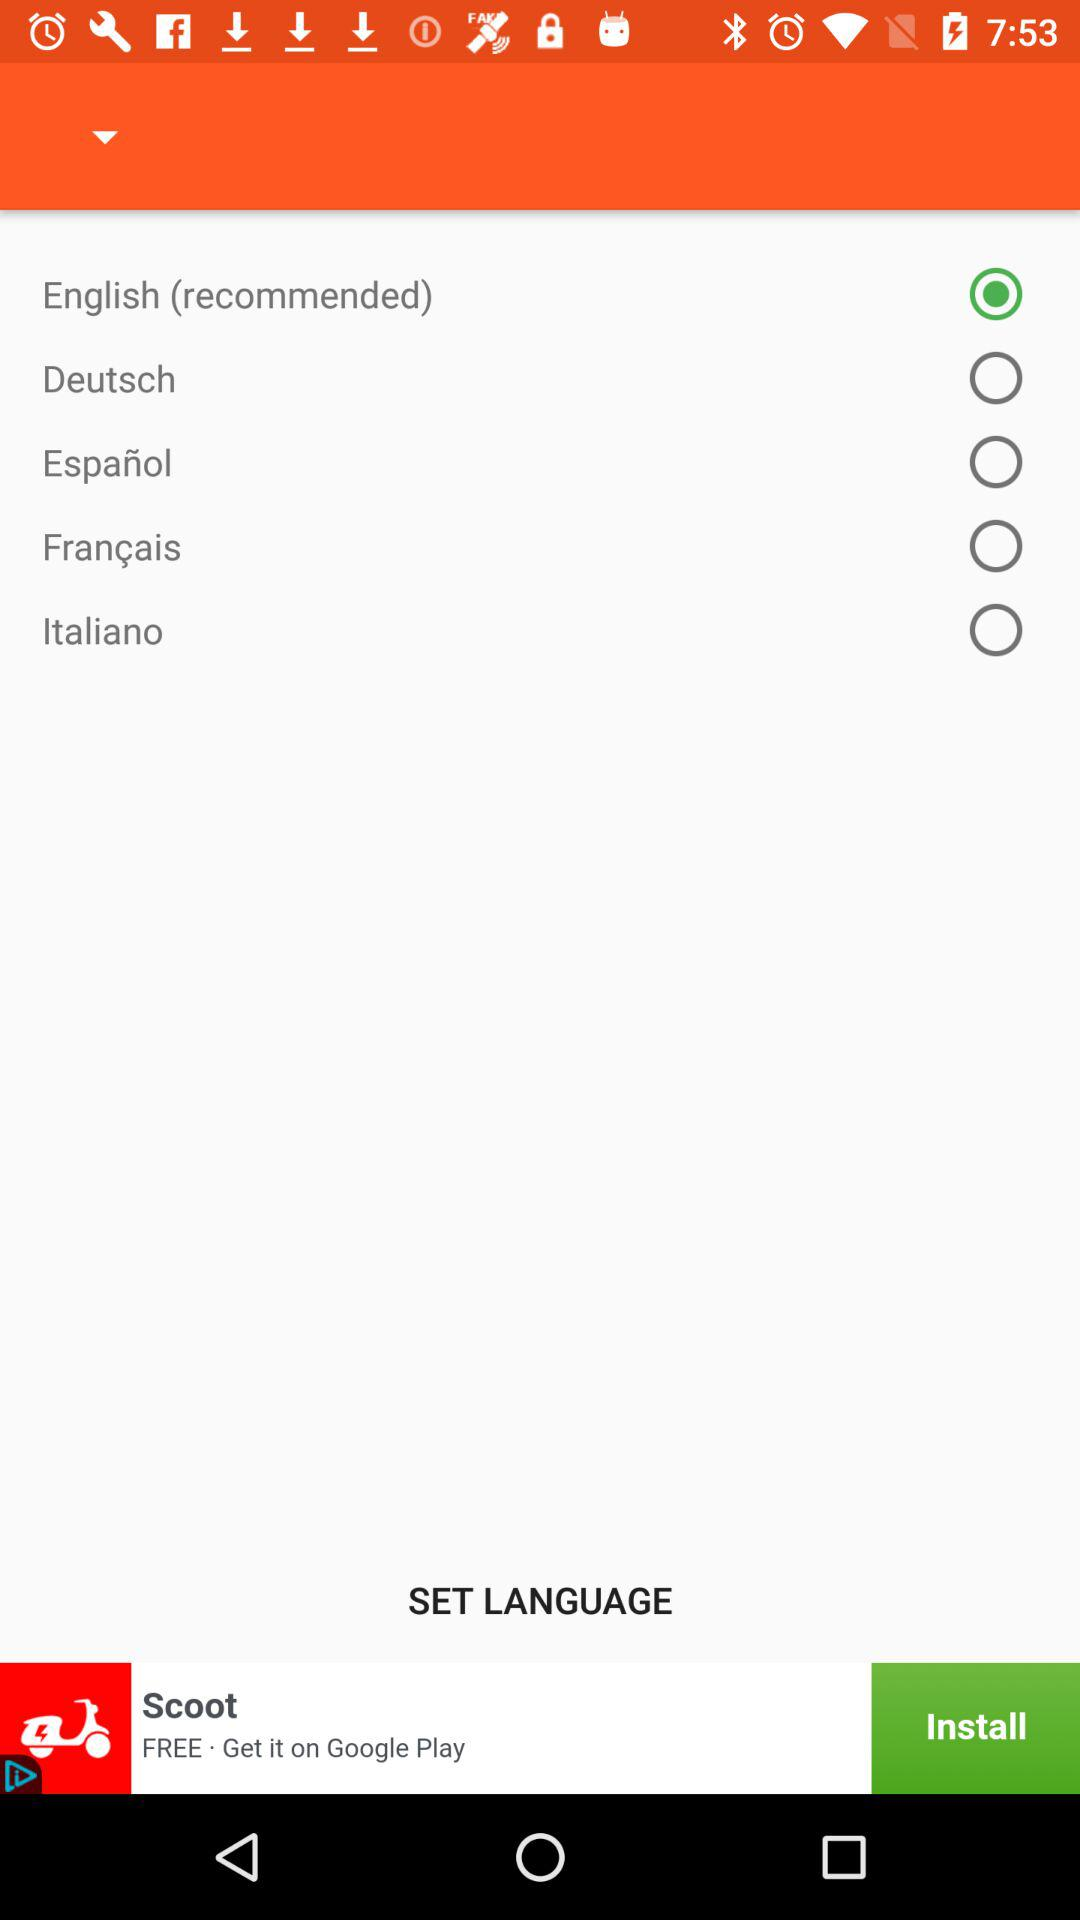What is the selected option? The selected option is "English (recommended)". 